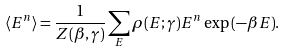<formula> <loc_0><loc_0><loc_500><loc_500>\langle E ^ { n } \rangle = \frac { 1 } { Z ( \beta , \gamma ) } \sum _ { E } \rho ( E ; \gamma ) E ^ { n } \exp { ( - \beta E ) } .</formula> 